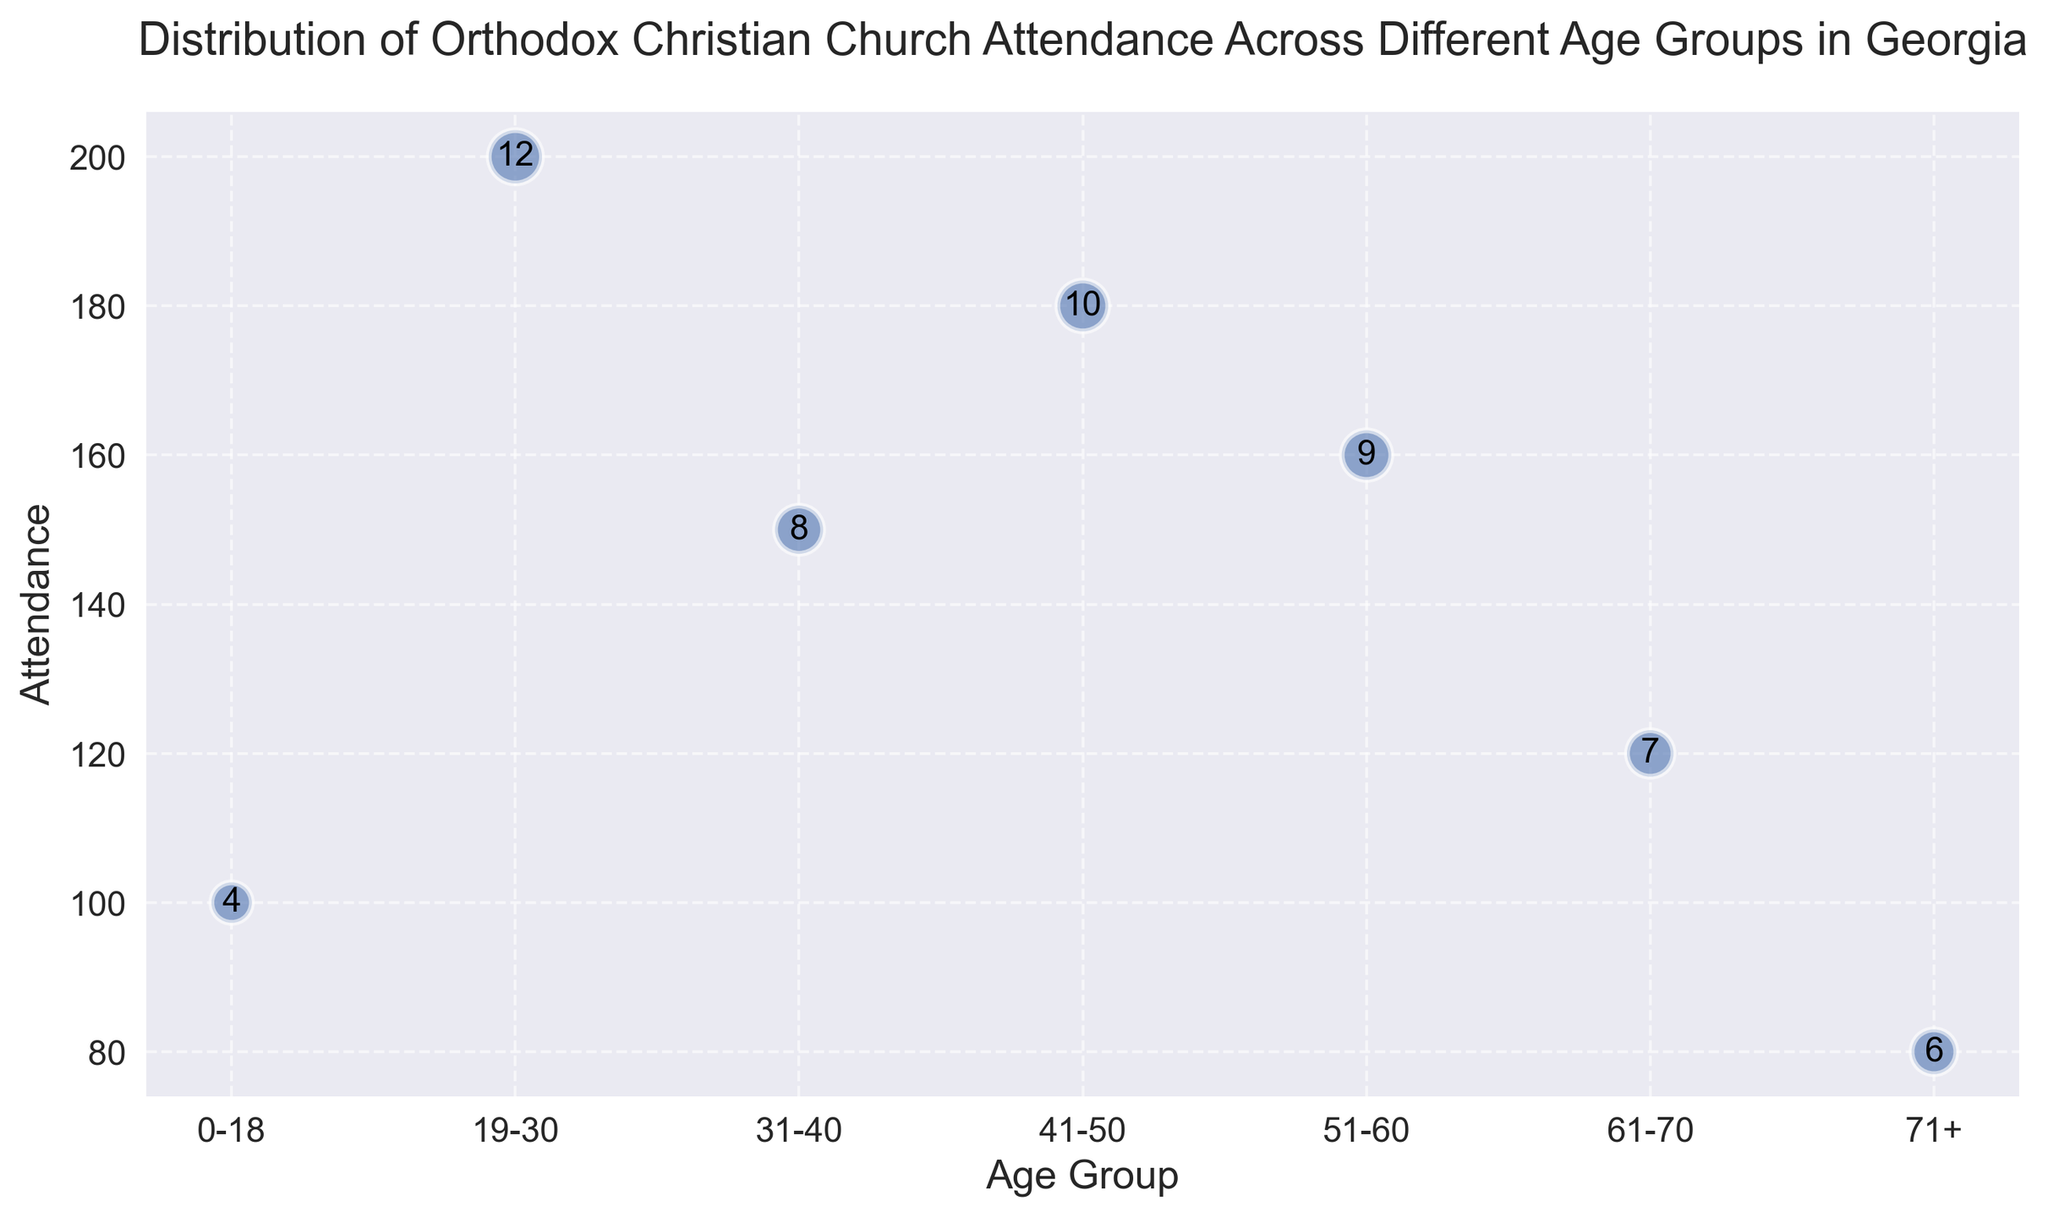What age group has the highest church attendance? By observing the heights of the bubbles, the age group "19-30" has the highest value on the y-axis, indicating the highest church attendance.
Answer: 19-30 What is the difference in church attendance between the age groups 41-50 and 0-18? The attendance for "41-50" is 180, and for "0-18" is 100. The difference is 180 - 100 = 80.
Answer: 80 Which age group attends church more frequently, 31-40 or 51-60? The bubble size is an indicator of frequency. The bubble for "51-60" is larger than "31-40", which means the frequency for "51-60" is higher.
Answer: 51-60 How does the church attendance for age group 61-70 compare to that of 71+? The attendance for "61-70" is 120 and for "71+" is 80. Comparing these, 120 is greater than 80.
Answer: Greater What is the average church attendance among all the age groups? The total attendance summed up is 100 + 200 + 150 + 180 + 160 + 120 + 80 = 990. There are 7 age groups, so the average is 990/7 = 141.43.
Answer: 141.43 Which age group has the smallest frequency of church attendance? The smallest bubble size, indicating frequency, is for the age group "0-18".
Answer: 0-18 Which age group has a frequency of 8? The bubble that has ‘8’ annotated inside it is for the age group "31-40".
Answer: 31-40 As the frequency increases, what general trend can be observed in church attendance across the age groups? Generally, higher frequencies are mapped with relatively higher attendance values, indicating that those groups with higher attendance tend to have higher frequencies. For instance, the age group "19-30" has the highest attendance and also one of the highest frequencies.
Answer: Higher frequencies are associated with higher attendances What is the total frequency of church attendance for age groups above 50? Age groups above 50 are "51-60" and "61-70" and "71+". Their frequencies are 9, 7, and 6 respectively. Adding them gives 9 + 7 + 6 = 22.
Answer: 22 